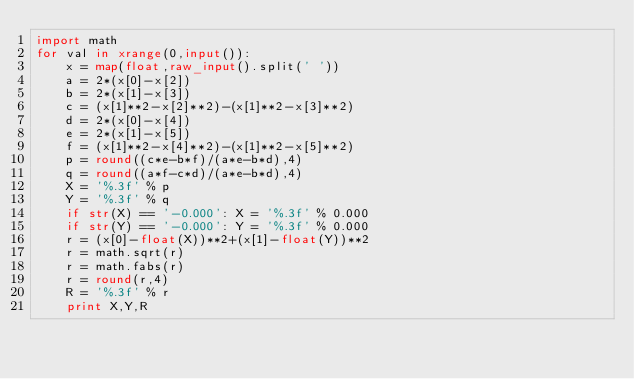Convert code to text. <code><loc_0><loc_0><loc_500><loc_500><_Python_>import math
for val in xrange(0,input()):
	x = map(float,raw_input().split(' '))
	a = 2*(x[0]-x[2])
	b = 2*(x[1]-x[3])
	c = (x[1]**2-x[2]**2)-(x[1]**2-x[3]**2)
	d = 2*(x[0]-x[4])
	e = 2*(x[1]-x[5])
	f = (x[1]**2-x[4]**2)-(x[1]**2-x[5]**2)
	p = round((c*e-b*f)/(a*e-b*d),4)
	q = round((a*f-c*d)/(a*e-b*d),4)
	X = '%.3f' % p
	Y = '%.3f' % q
	if str(X) == '-0.000': X = '%.3f' % 0.000
	if str(Y) == '-0.000': Y = '%.3f' % 0.000
	r = (x[0]-float(X))**2+(x[1]-float(Y))**2
	r = math.sqrt(r)
	r = math.fabs(r)
	r = round(r,4)
	R = '%.3f' % r
	print X,Y,R</code> 